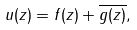<formula> <loc_0><loc_0><loc_500><loc_500>u ( z ) = f ( z ) + \overline { g ( z ) } ,</formula> 